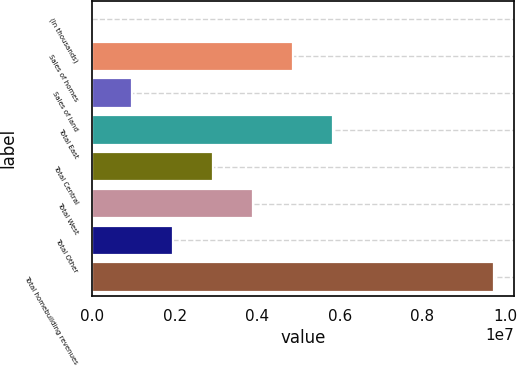Convert chart to OTSL. <chart><loc_0><loc_0><loc_500><loc_500><bar_chart><fcel>(In thousands)<fcel>Sales of homes<fcel>Sales of land<fcel>Total East<fcel>Total Central<fcel>Total West<fcel>Total Other<fcel>Total homebuilding revenues<nl><fcel>2016<fcel>4.87168e+06<fcel>975948<fcel>5.84561e+06<fcel>2.92381e+06<fcel>3.89774e+06<fcel>1.94988e+06<fcel>9.74134e+06<nl></chart> 